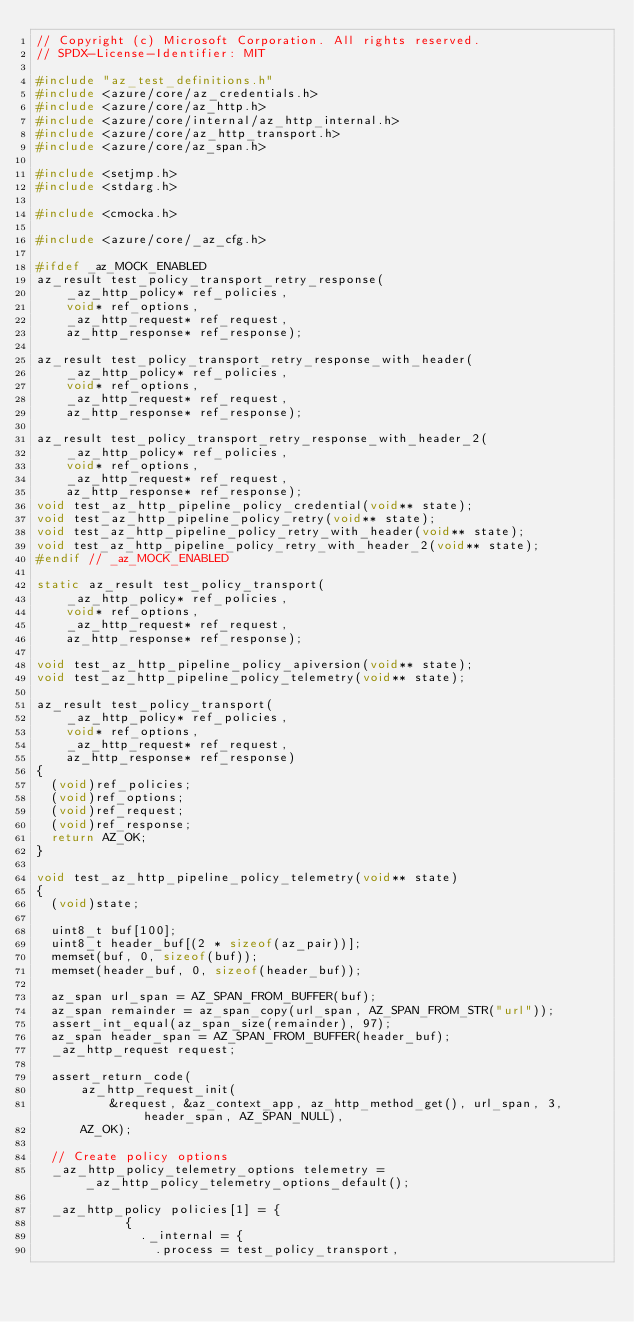Convert code to text. <code><loc_0><loc_0><loc_500><loc_500><_C_>// Copyright (c) Microsoft Corporation. All rights reserved.
// SPDX-License-Identifier: MIT

#include "az_test_definitions.h"
#include <azure/core/az_credentials.h>
#include <azure/core/az_http.h>
#include <azure/core/internal/az_http_internal.h>
#include <azure/core/az_http_transport.h>
#include <azure/core/az_span.h>

#include <setjmp.h>
#include <stdarg.h>

#include <cmocka.h>

#include <azure/core/_az_cfg.h>

#ifdef _az_MOCK_ENABLED
az_result test_policy_transport_retry_response(
    _az_http_policy* ref_policies,
    void* ref_options,
    _az_http_request* ref_request,
    az_http_response* ref_response);

az_result test_policy_transport_retry_response_with_header(
    _az_http_policy* ref_policies,
    void* ref_options,
    _az_http_request* ref_request,
    az_http_response* ref_response);

az_result test_policy_transport_retry_response_with_header_2(
    _az_http_policy* ref_policies,
    void* ref_options,
    _az_http_request* ref_request,
    az_http_response* ref_response);
void test_az_http_pipeline_policy_credential(void** state);
void test_az_http_pipeline_policy_retry(void** state);
void test_az_http_pipeline_policy_retry_with_header(void** state);
void test_az_http_pipeline_policy_retry_with_header_2(void** state);
#endif // _az_MOCK_ENABLED

static az_result test_policy_transport(
    _az_http_policy* ref_policies,
    void* ref_options,
    _az_http_request* ref_request,
    az_http_response* ref_response);

void test_az_http_pipeline_policy_apiversion(void** state);
void test_az_http_pipeline_policy_telemetry(void** state);

az_result test_policy_transport(
    _az_http_policy* ref_policies,
    void* ref_options,
    _az_http_request* ref_request,
    az_http_response* ref_response)
{
  (void)ref_policies;
  (void)ref_options;
  (void)ref_request;
  (void)ref_response;
  return AZ_OK;
}

void test_az_http_pipeline_policy_telemetry(void** state)
{
  (void)state;

  uint8_t buf[100];
  uint8_t header_buf[(2 * sizeof(az_pair))];
  memset(buf, 0, sizeof(buf));
  memset(header_buf, 0, sizeof(header_buf));

  az_span url_span = AZ_SPAN_FROM_BUFFER(buf);
  az_span remainder = az_span_copy(url_span, AZ_SPAN_FROM_STR("url"));
  assert_int_equal(az_span_size(remainder), 97);
  az_span header_span = AZ_SPAN_FROM_BUFFER(header_buf);
  _az_http_request request;

  assert_return_code(
      az_http_request_init(
          &request, &az_context_app, az_http_method_get(), url_span, 3, header_span, AZ_SPAN_NULL),
      AZ_OK);

  // Create policy options
  _az_http_policy_telemetry_options telemetry = _az_http_policy_telemetry_options_default();

  _az_http_policy policies[1] = {            
            {
              ._internal = {
                .process = test_policy_transport,</code> 